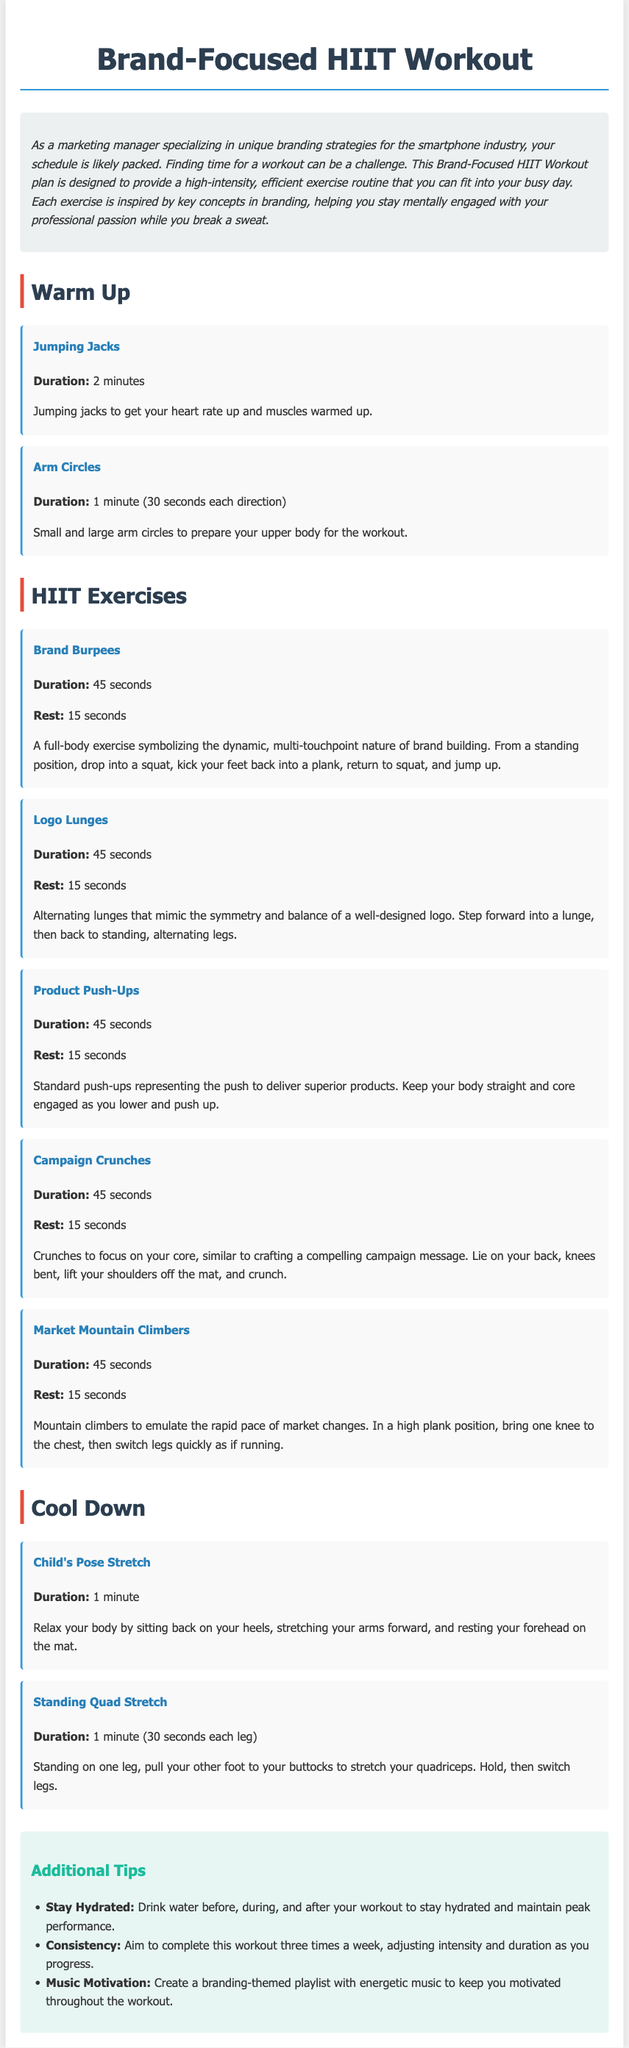What is the main purpose of the Brand-Focused HIIT Workout? The introduction section explains that the workout plan is designed to provide a high-intensity, efficient exercise routine for busy marketing professionals.
Answer: efficient exercise routine How long is the duration of the Jumping Jacks warm-up exercise? The duration for Jumping Jacks is specified in the warm-up section of the document.
Answer: 2 minutes What is the rest period after Brand Burpees? The rest time between sets of Brand Burpees is stated in the HIIT Exercises section.
Answer: 15 seconds How many times a week should one aim to complete this workout? Consistency advice given in the tips section indicates the suggested frequency of the workout.
Answer: three times What does Market Mountain Climbers emulate? The description explains that Market Mountain Climbers mimic the rapid pace of market changes.
Answer: rapid pace of market changes What exercise focuses on the core similar to crafting a compelling campaign message? Referencing the HIIT Exercises section, the exercise that targets the core is explicitly mentioned.
Answer: Campaign Crunches What is the duration for the Standing Quad Stretch? The duration for the Standing Quad Stretch is provided in the cool-down section.
Answer: 1 minute (30 seconds each leg) What type of music is recommended for motivation during the workout? The tips section advises creating a branding-themed playlist for motivation.
Answer: branding-themed playlist 